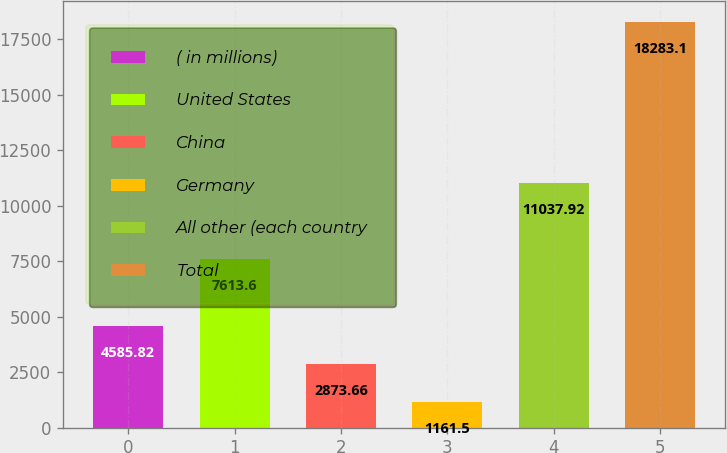Convert chart to OTSL. <chart><loc_0><loc_0><loc_500><loc_500><bar_chart><fcel>( in millions)<fcel>United States<fcel>China<fcel>Germany<fcel>All other (each country<fcel>Total<nl><fcel>4585.82<fcel>7613.6<fcel>2873.66<fcel>1161.5<fcel>11037.9<fcel>18283.1<nl></chart> 